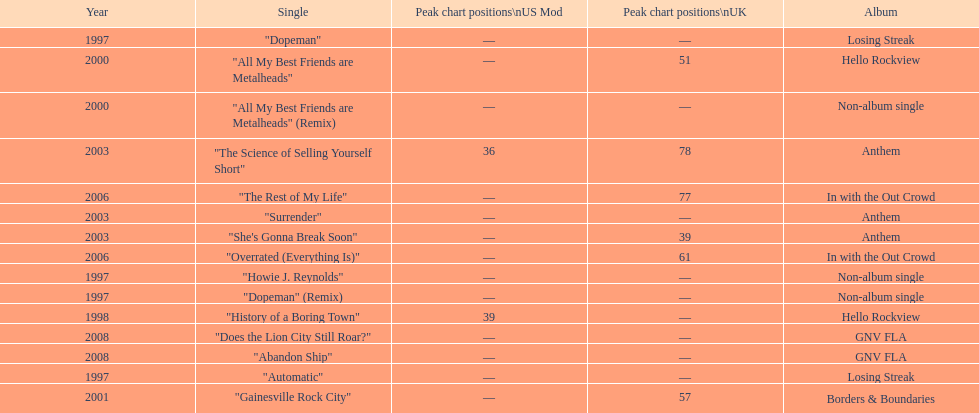What was the first single to earn a chart position? "History of a Boring Town". 